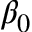<formula> <loc_0><loc_0><loc_500><loc_500>\beta _ { 0 }</formula> 